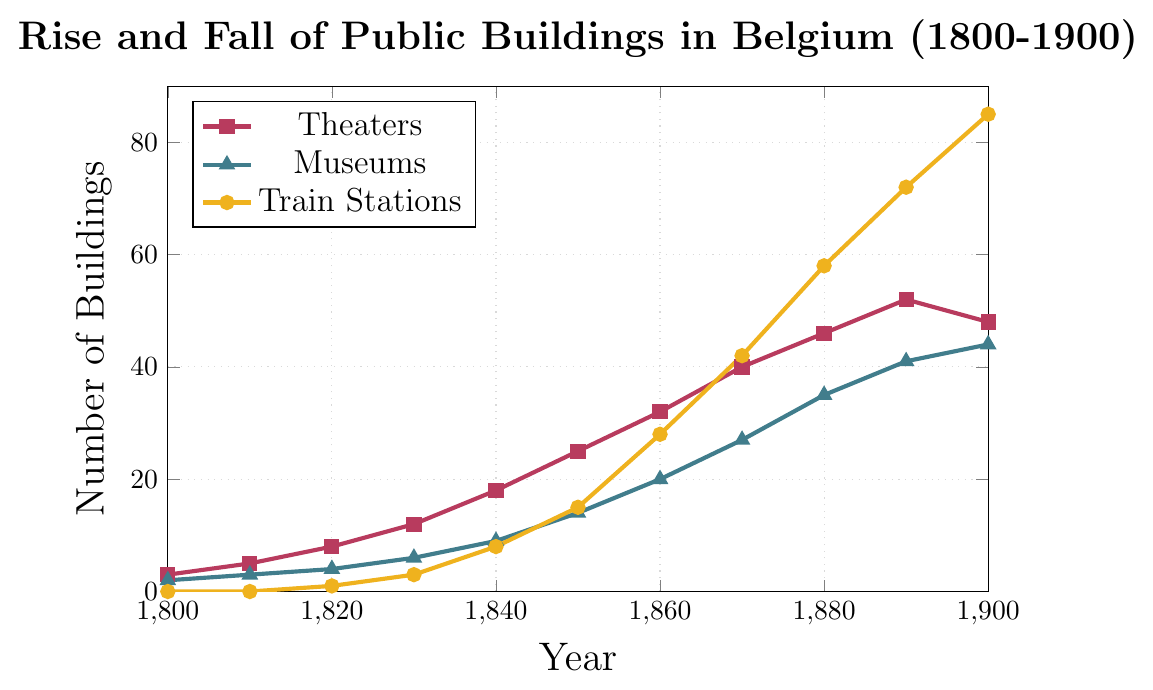Which type of building saw the largest growth in number from 1800 to 1900? Compare the number of each type of building in 1800 and 1900: Theaters increased from 3 to 48 (growth of 45), Museums from 2 to 44 (growth of 42), and Train Stations from 0 to 85 (growth of 85).
Answer: Train Stations Between which consecutive decades did Theaters experience the highest absolute increase in number? Calculate the increase for each decade: 
1810-1800: 2, 1820-1810: 3, 1830-1820: 4, 1840-1830: 6, 1850-1840: 7, 1860-1850: 7, 1870-1860: 8, 1880-1870: 6, 1890-1880: 6, 1900-1890: -4. The largest increase is 8 (1870-1860).
Answer: Between 1860 and 1870 Which type of building showed a decrease in number in the last decade (1890-1900)? Analyze the data between 1890 and 1900: Theaters decreased from 52 to 48, while Museums and Train Stations increased.
Answer: Theaters What was the total number of Theaters, Museums, and Train Stations in 1860? Add the numbers for Theaters (32), Museums (20), and Train Stations (28) in 1860. 32 + 20 + 28 = 80.
Answer: 80 In which decade did Museums surpass Theaters in number for the first time? By checking the values, Museums never surpassed Theaters in number throughout the entire period.
Answer: They never did How many more Train Stations were there compared to Museums in 1900? Subtract the number of Museums from Train Stations in 1900: 85 (Train Stations) - 44 (Museums) = 41.
Answer: 41 Which type of building had the slowest growth rate between 1800 and 1850? Calculate the difference between 1850 and 1800 for each type: Theaters: 25 - 3 = 22, Museums: 14 - 2 = 12, Train Stations: 15 - 0 = 15. The slowest growth is for Museums (12).
Answer: Museums How many Theaters, Museums, and Train Stations were there in 1840 combined? Sum the numbers for Theaters (18), Museums (9), and Train Stations (8) in 1840: 18 + 9 + 8 = 35.
Answer: 35 What is the average number of buildings (all types combined) in 1870? Calculate the average for 1870: (40 (Theaters) + 27 (Museums) + 42 (Train Stations)) / 3 = 109 / 3 ≈ 36.33.
Answer: 36.33 